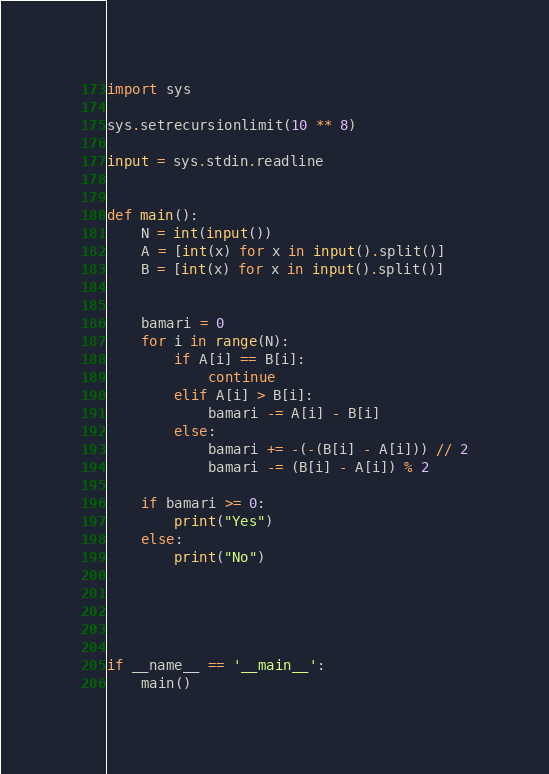Convert code to text. <code><loc_0><loc_0><loc_500><loc_500><_Python_>import sys

sys.setrecursionlimit(10 ** 8)

input = sys.stdin.readline


def main():
    N = int(input())
    A = [int(x) for x in input().split()]
    B = [int(x) for x in input().split()]


    bamari = 0
    for i in range(N):
        if A[i] == B[i]:
            continue
        elif A[i] > B[i]:
            bamari -= A[i] - B[i]
        else:
            bamari += -(-(B[i] - A[i])) // 2
            bamari -= (B[i] - A[i]) % 2

    if bamari >= 0:
        print("Yes")
    else:
        print("No")



    

if __name__ == '__main__':
    main()

</code> 